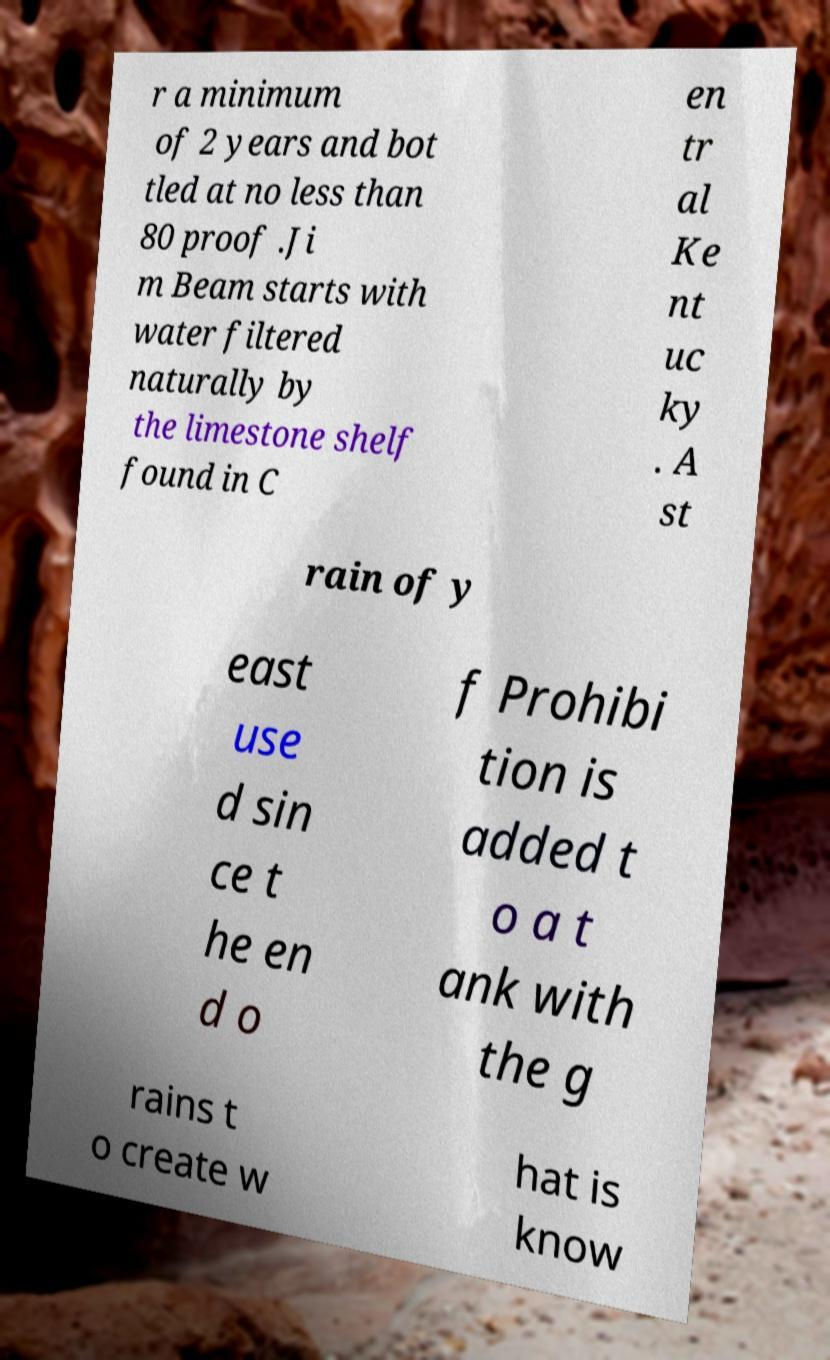What messages or text are displayed in this image? I need them in a readable, typed format. r a minimum of 2 years and bot tled at no less than 80 proof .Ji m Beam starts with water filtered naturally by the limestone shelf found in C en tr al Ke nt uc ky . A st rain of y east use d sin ce t he en d o f Prohibi tion is added t o a t ank with the g rains t o create w hat is know 